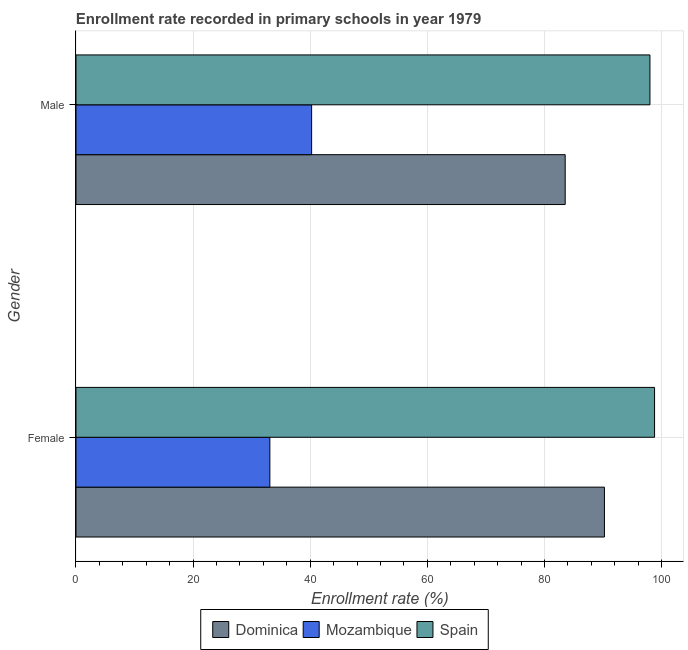Are the number of bars per tick equal to the number of legend labels?
Provide a short and direct response. Yes. What is the label of the 2nd group of bars from the top?
Ensure brevity in your answer.  Female. What is the enrollment rate of male students in Dominica?
Offer a very short reply. 83.55. Across all countries, what is the maximum enrollment rate of female students?
Offer a very short reply. 98.81. Across all countries, what is the minimum enrollment rate of female students?
Your answer should be very brief. 33.11. In which country was the enrollment rate of female students maximum?
Provide a succinct answer. Spain. In which country was the enrollment rate of female students minimum?
Your response must be concise. Mozambique. What is the total enrollment rate of male students in the graph?
Your answer should be very brief. 221.81. What is the difference between the enrollment rate of male students in Dominica and that in Spain?
Offer a very short reply. -14.47. What is the difference between the enrollment rate of female students in Dominica and the enrollment rate of male students in Mozambique?
Give a very brief answer. 50. What is the average enrollment rate of female students per country?
Offer a very short reply. 74.05. What is the difference between the enrollment rate of female students and enrollment rate of male students in Spain?
Ensure brevity in your answer.  0.79. What is the ratio of the enrollment rate of female students in Spain to that in Dominica?
Offer a very short reply. 1.09. Is the enrollment rate of male students in Spain less than that in Mozambique?
Offer a terse response. No. In how many countries, is the enrollment rate of female students greater than the average enrollment rate of female students taken over all countries?
Your answer should be compact. 2. What does the 3rd bar from the top in Male represents?
Your answer should be very brief. Dominica. What does the 1st bar from the bottom in Female represents?
Your answer should be very brief. Dominica. How many bars are there?
Give a very brief answer. 6. How many countries are there in the graph?
Provide a succinct answer. 3. What is the difference between two consecutive major ticks on the X-axis?
Your answer should be very brief. 20. Are the values on the major ticks of X-axis written in scientific E-notation?
Keep it short and to the point. No. How are the legend labels stacked?
Offer a terse response. Horizontal. What is the title of the graph?
Ensure brevity in your answer.  Enrollment rate recorded in primary schools in year 1979. What is the label or title of the X-axis?
Make the answer very short. Enrollment rate (%). What is the label or title of the Y-axis?
Provide a short and direct response. Gender. What is the Enrollment rate (%) of Dominica in Female?
Offer a very short reply. 90.24. What is the Enrollment rate (%) in Mozambique in Female?
Offer a terse response. 33.11. What is the Enrollment rate (%) of Spain in Female?
Keep it short and to the point. 98.81. What is the Enrollment rate (%) of Dominica in Male?
Ensure brevity in your answer.  83.55. What is the Enrollment rate (%) in Mozambique in Male?
Offer a very short reply. 40.24. What is the Enrollment rate (%) in Spain in Male?
Ensure brevity in your answer.  98.02. Across all Gender, what is the maximum Enrollment rate (%) in Dominica?
Offer a very short reply. 90.24. Across all Gender, what is the maximum Enrollment rate (%) in Mozambique?
Provide a short and direct response. 40.24. Across all Gender, what is the maximum Enrollment rate (%) of Spain?
Ensure brevity in your answer.  98.81. Across all Gender, what is the minimum Enrollment rate (%) of Dominica?
Your answer should be compact. 83.55. Across all Gender, what is the minimum Enrollment rate (%) of Mozambique?
Give a very brief answer. 33.11. Across all Gender, what is the minimum Enrollment rate (%) of Spain?
Your response must be concise. 98.02. What is the total Enrollment rate (%) in Dominica in the graph?
Keep it short and to the point. 173.79. What is the total Enrollment rate (%) in Mozambique in the graph?
Offer a terse response. 73.35. What is the total Enrollment rate (%) in Spain in the graph?
Ensure brevity in your answer.  196.83. What is the difference between the Enrollment rate (%) of Dominica in Female and that in Male?
Provide a succinct answer. 6.7. What is the difference between the Enrollment rate (%) in Mozambique in Female and that in Male?
Your response must be concise. -7.13. What is the difference between the Enrollment rate (%) of Spain in Female and that in Male?
Your answer should be compact. 0.79. What is the difference between the Enrollment rate (%) of Dominica in Female and the Enrollment rate (%) of Mozambique in Male?
Keep it short and to the point. 50. What is the difference between the Enrollment rate (%) in Dominica in Female and the Enrollment rate (%) in Spain in Male?
Offer a terse response. -7.77. What is the difference between the Enrollment rate (%) of Mozambique in Female and the Enrollment rate (%) of Spain in Male?
Ensure brevity in your answer.  -64.91. What is the average Enrollment rate (%) in Dominica per Gender?
Your response must be concise. 86.89. What is the average Enrollment rate (%) in Mozambique per Gender?
Your answer should be compact. 36.68. What is the average Enrollment rate (%) in Spain per Gender?
Offer a terse response. 98.41. What is the difference between the Enrollment rate (%) of Dominica and Enrollment rate (%) of Mozambique in Female?
Your response must be concise. 57.13. What is the difference between the Enrollment rate (%) in Dominica and Enrollment rate (%) in Spain in Female?
Keep it short and to the point. -8.56. What is the difference between the Enrollment rate (%) of Mozambique and Enrollment rate (%) of Spain in Female?
Ensure brevity in your answer.  -65.7. What is the difference between the Enrollment rate (%) of Dominica and Enrollment rate (%) of Mozambique in Male?
Keep it short and to the point. 43.3. What is the difference between the Enrollment rate (%) of Dominica and Enrollment rate (%) of Spain in Male?
Keep it short and to the point. -14.47. What is the difference between the Enrollment rate (%) of Mozambique and Enrollment rate (%) of Spain in Male?
Your answer should be very brief. -57.78. What is the ratio of the Enrollment rate (%) in Dominica in Female to that in Male?
Offer a very short reply. 1.08. What is the ratio of the Enrollment rate (%) of Mozambique in Female to that in Male?
Give a very brief answer. 0.82. What is the difference between the highest and the second highest Enrollment rate (%) in Dominica?
Your answer should be compact. 6.7. What is the difference between the highest and the second highest Enrollment rate (%) in Mozambique?
Keep it short and to the point. 7.13. What is the difference between the highest and the second highest Enrollment rate (%) in Spain?
Provide a succinct answer. 0.79. What is the difference between the highest and the lowest Enrollment rate (%) of Dominica?
Ensure brevity in your answer.  6.7. What is the difference between the highest and the lowest Enrollment rate (%) in Mozambique?
Your response must be concise. 7.13. What is the difference between the highest and the lowest Enrollment rate (%) in Spain?
Your answer should be very brief. 0.79. 